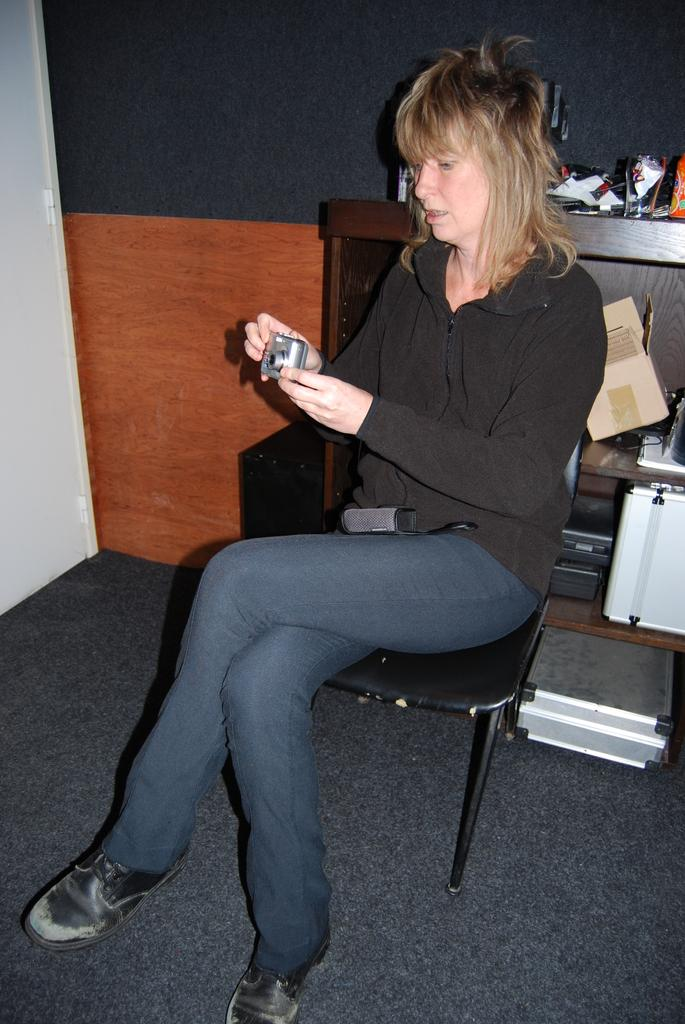What is the woman in the image doing? The woman is sitting on a chair and holding a camera with her hands. What can be seen on the floor in the image? The floor is visible in the image. What is present in the background of the image? There is a cardboard, a box, and devices in the background. What type of surface is visible in the image? There is a wall visible in the image. What type of crown is the woman wearing in the image? There is no crown present in the image; the woman is holding a camera. 